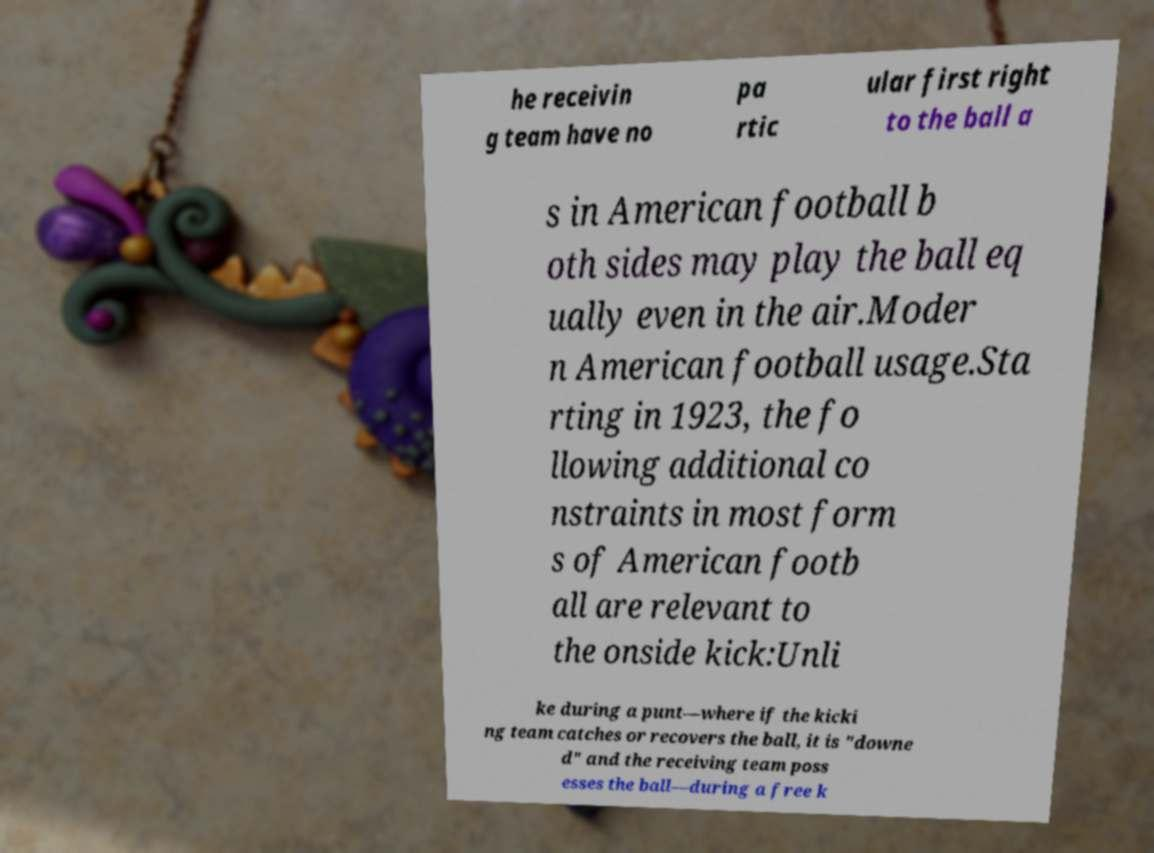Please read and relay the text visible in this image. What does it say? he receivin g team have no pa rtic ular first right to the ball a s in American football b oth sides may play the ball eq ually even in the air.Moder n American football usage.Sta rting in 1923, the fo llowing additional co nstraints in most form s of American footb all are relevant to the onside kick:Unli ke during a punt—where if the kicki ng team catches or recovers the ball, it is "downe d" and the receiving team poss esses the ball—during a free k 